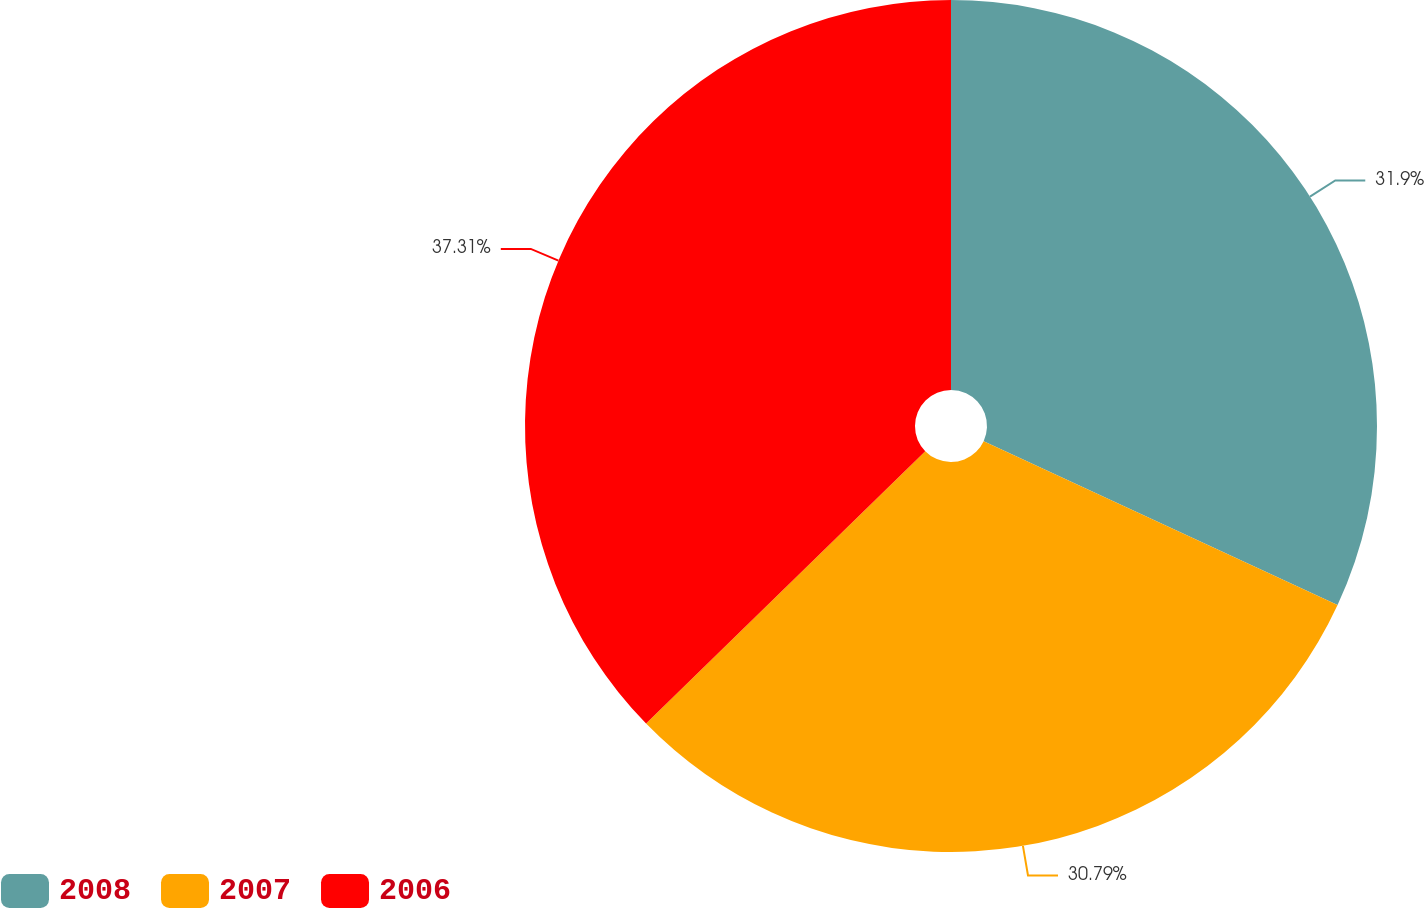Convert chart. <chart><loc_0><loc_0><loc_500><loc_500><pie_chart><fcel>2008<fcel>2007<fcel>2006<nl><fcel>31.9%<fcel>30.79%<fcel>37.3%<nl></chart> 